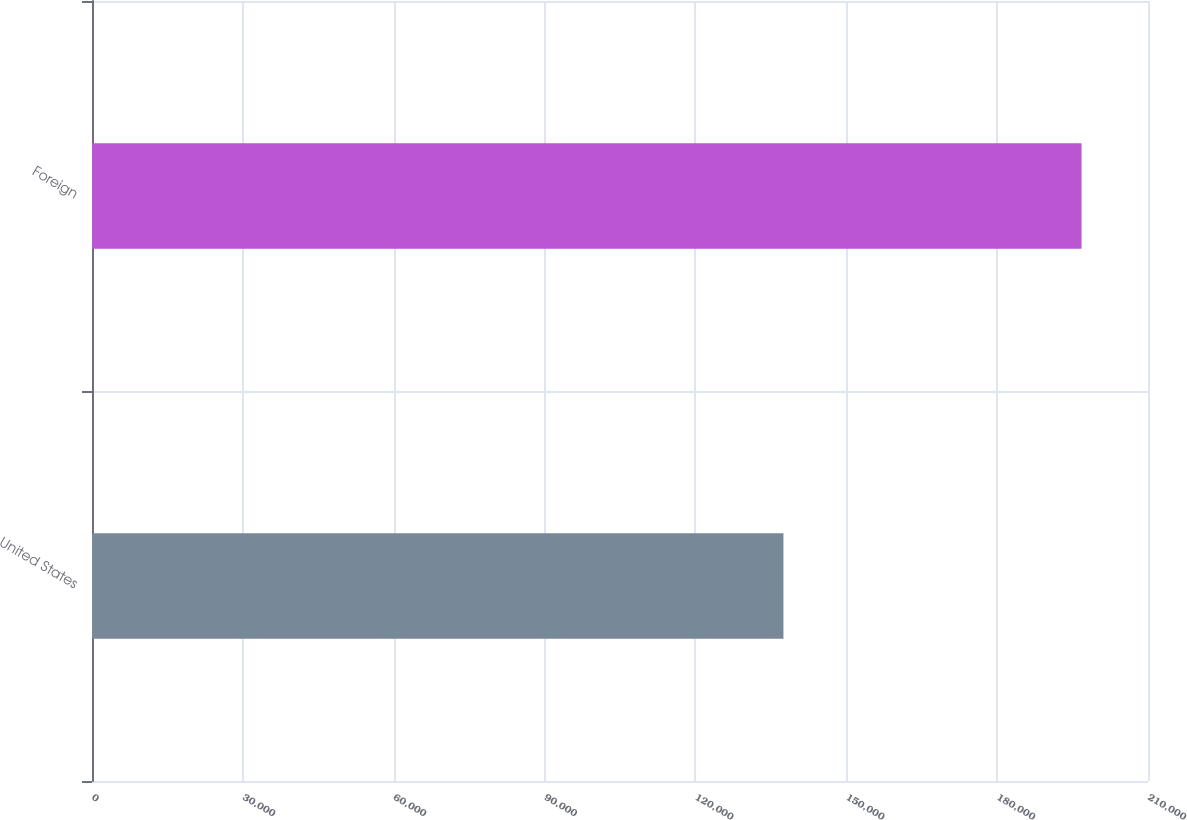<chart> <loc_0><loc_0><loc_500><loc_500><bar_chart><fcel>United States<fcel>Foreign<nl><fcel>137501<fcel>196783<nl></chart> 